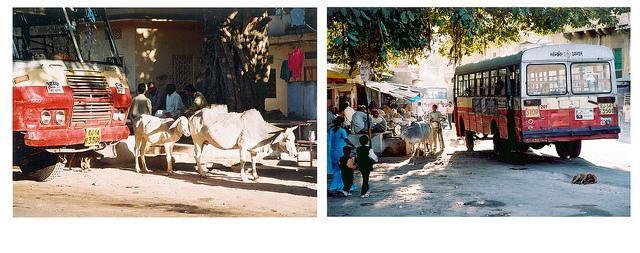How many wheels are on the bus?
Give a very brief answer. 6. How many cows are in the picture?
Give a very brief answer. 2. How many buses are in the picture?
Give a very brief answer. 2. 